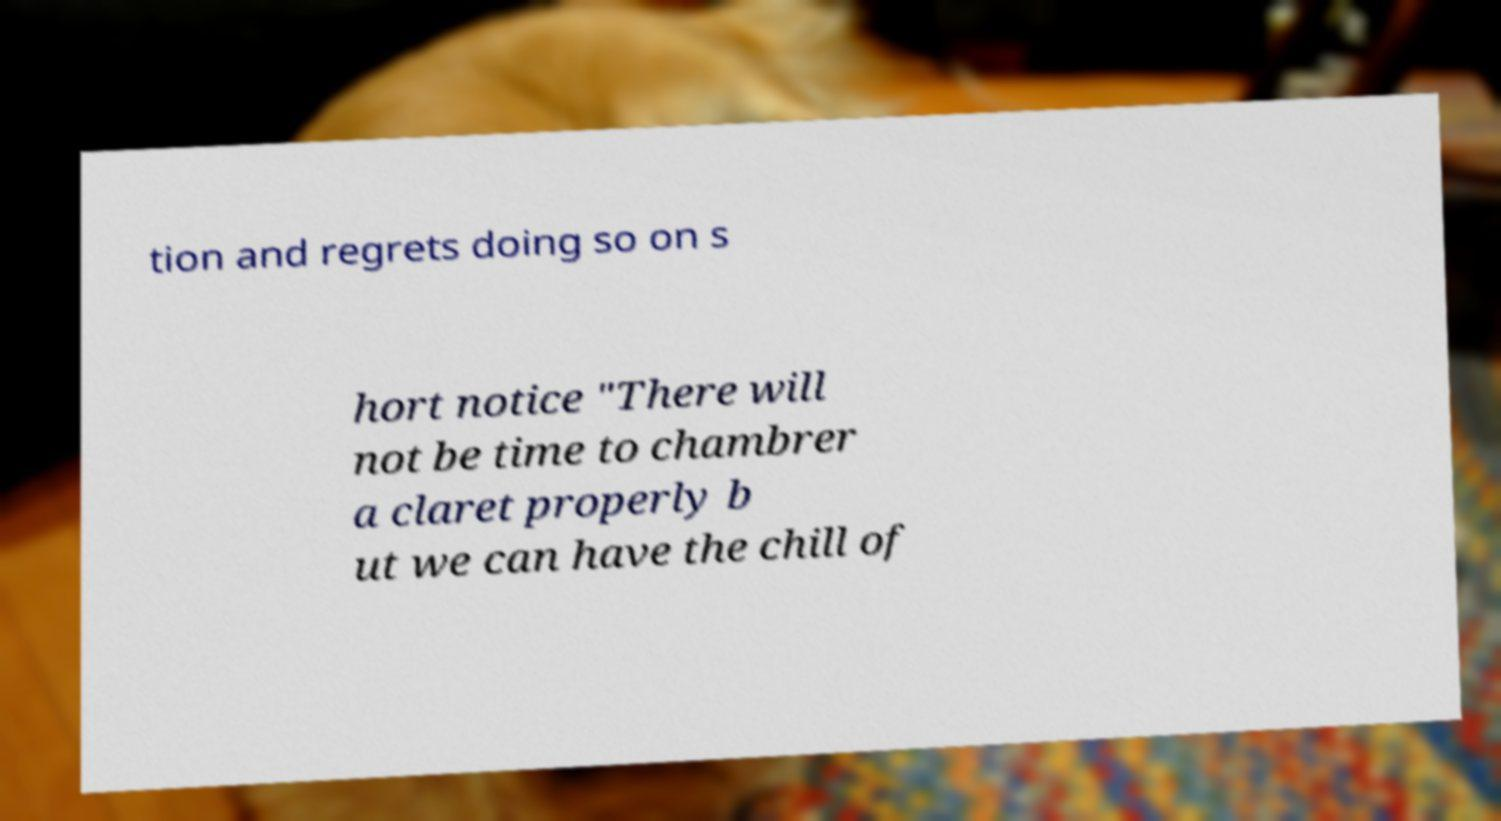Can you read and provide the text displayed in the image?This photo seems to have some interesting text. Can you extract and type it out for me? tion and regrets doing so on s hort notice "There will not be time to chambrer a claret properly b ut we can have the chill of 